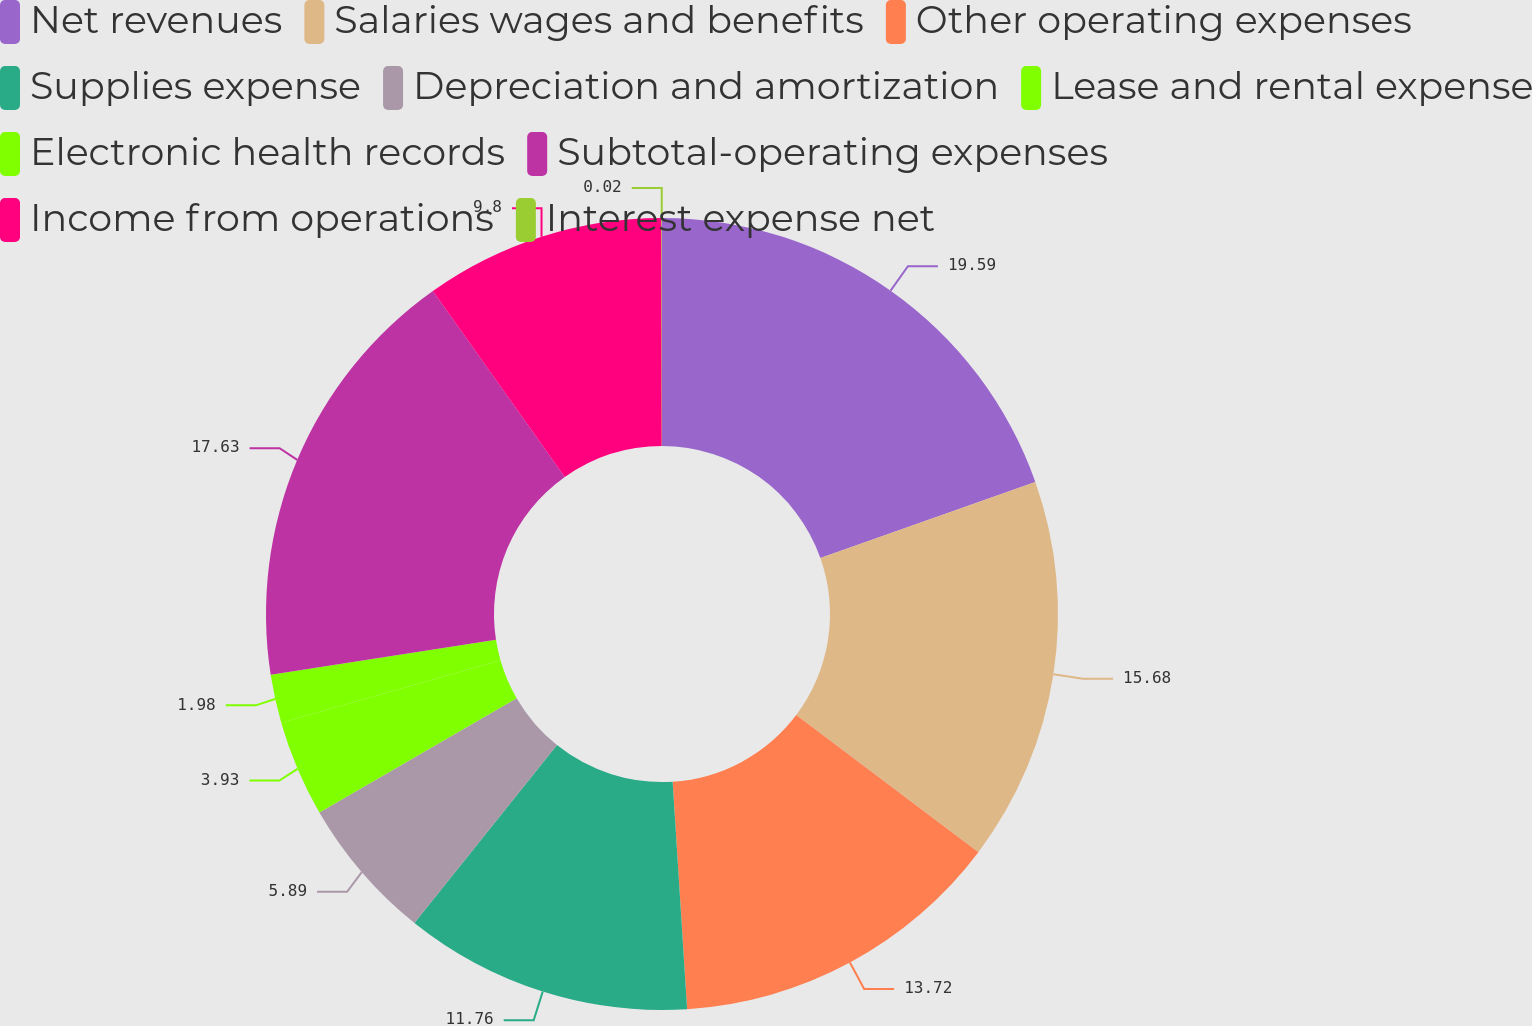Convert chart to OTSL. <chart><loc_0><loc_0><loc_500><loc_500><pie_chart><fcel>Net revenues<fcel>Salaries wages and benefits<fcel>Other operating expenses<fcel>Supplies expense<fcel>Depreciation and amortization<fcel>Lease and rental expense<fcel>Electronic health records<fcel>Subtotal-operating expenses<fcel>Income from operations<fcel>Interest expense net<nl><fcel>19.59%<fcel>15.68%<fcel>13.72%<fcel>11.76%<fcel>5.89%<fcel>3.93%<fcel>1.98%<fcel>17.63%<fcel>9.8%<fcel>0.02%<nl></chart> 